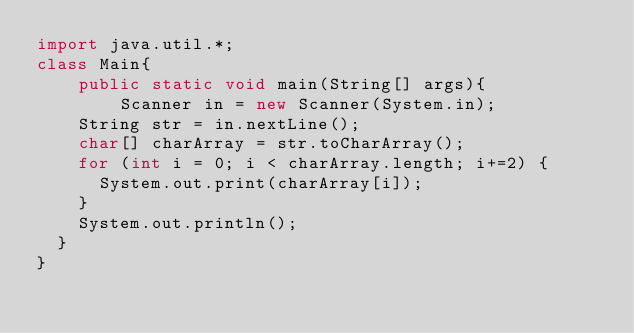<code> <loc_0><loc_0><loc_500><loc_500><_Java_>import java.util.*;
class Main{
    public static void main(String[] args){
        Scanner in = new Scanner(System.in);
		String str = in.nextLine();
		char[] charArray = str.toCharArray();
		for (int i = 0; i < charArray.length; i+=2) {
			System.out.print(charArray[i]);
		}
		System.out.println();
	}
}</code> 